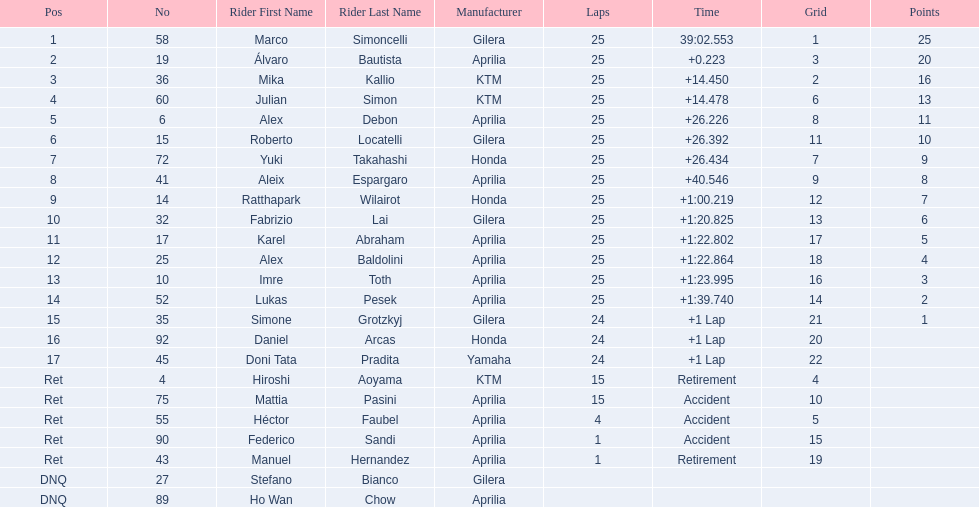How many laps did hiroshi aoyama perform? 15. How many laps did marco simoncelli perform? 25. Who performed more laps out of hiroshi aoyama and marco 
simoncelli? Marco Simoncelli. 